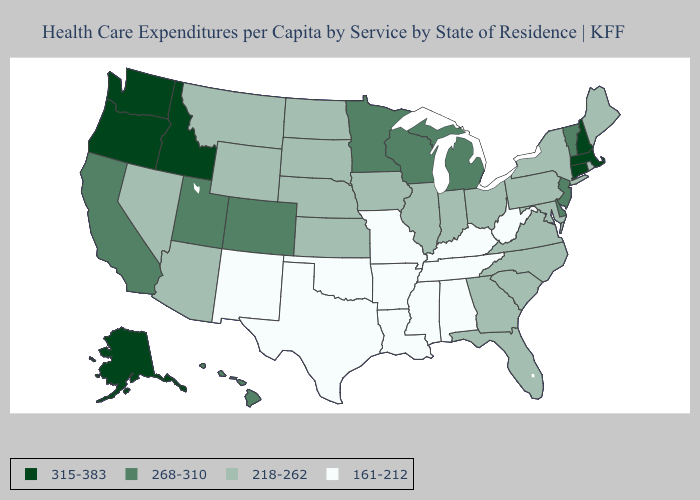Is the legend a continuous bar?
Answer briefly. No. Does Oklahoma have the lowest value in the USA?
Concise answer only. Yes. Does Connecticut have the highest value in the USA?
Concise answer only. Yes. Does New Hampshire have the highest value in the USA?
Concise answer only. Yes. Which states hav the highest value in the South?
Be succinct. Delaware. What is the highest value in the USA?
Give a very brief answer. 315-383. Name the states that have a value in the range 315-383?
Short answer required. Alaska, Connecticut, Idaho, Massachusetts, New Hampshire, Oregon, Washington. What is the value of Arizona?
Answer briefly. 218-262. What is the value of Iowa?
Be succinct. 218-262. Name the states that have a value in the range 315-383?
Short answer required. Alaska, Connecticut, Idaho, Massachusetts, New Hampshire, Oregon, Washington. Does Oregon have the same value as Florida?
Quick response, please. No. Name the states that have a value in the range 315-383?
Write a very short answer. Alaska, Connecticut, Idaho, Massachusetts, New Hampshire, Oregon, Washington. Among the states that border Maryland , which have the lowest value?
Concise answer only. West Virginia. Among the states that border Idaho , which have the highest value?
Write a very short answer. Oregon, Washington. 